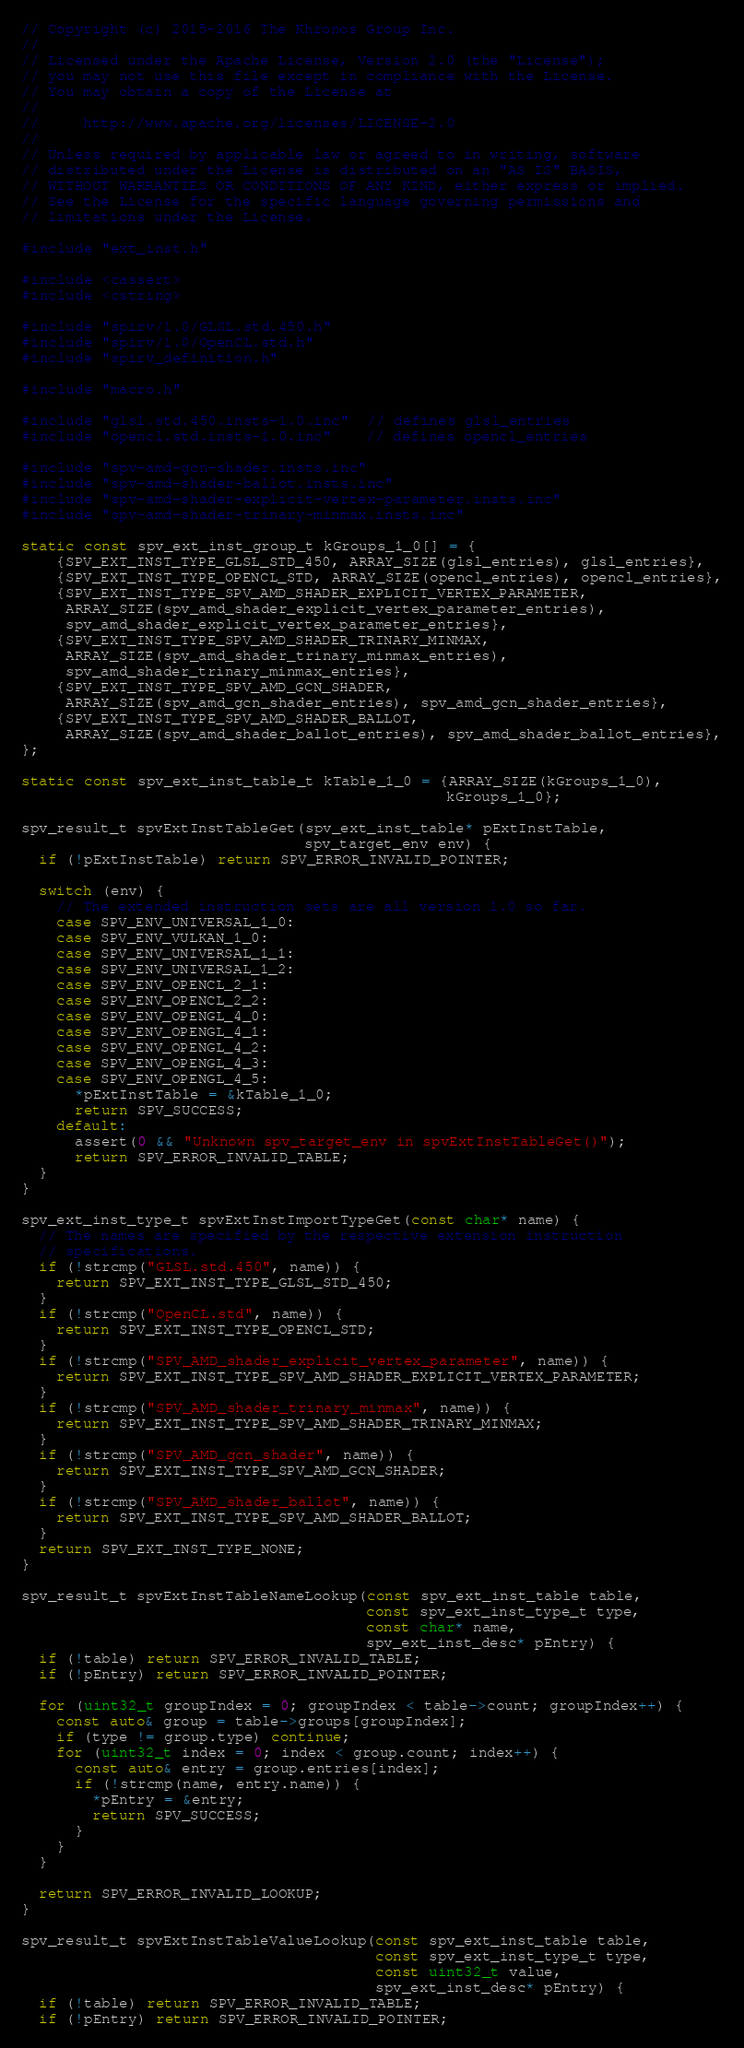Convert code to text. <code><loc_0><loc_0><loc_500><loc_500><_C++_>// Copyright (c) 2015-2016 The Khronos Group Inc.
//
// Licensed under the Apache License, Version 2.0 (the "License");
// you may not use this file except in compliance with the License.
// You may obtain a copy of the License at
//
//     http://www.apache.org/licenses/LICENSE-2.0
//
// Unless required by applicable law or agreed to in writing, software
// distributed under the License is distributed on an "AS IS" BASIS,
// WITHOUT WARRANTIES OR CONDITIONS OF ANY KIND, either express or implied.
// See the License for the specific language governing permissions and
// limitations under the License.

#include "ext_inst.h"

#include <cassert>
#include <cstring>

#include "spirv/1.0/GLSL.std.450.h"
#include "spirv/1.0/OpenCL.std.h"
#include "spirv_definition.h"

#include "macro.h"

#include "glsl.std.450.insts-1.0.inc"  // defines glsl_entries
#include "opencl.std.insts-1.0.inc"    // defines opencl_entries

#include "spv-amd-gcn-shader.insts.inc"
#include "spv-amd-shader-ballot.insts.inc"
#include "spv-amd-shader-explicit-vertex-parameter.insts.inc"
#include "spv-amd-shader-trinary-minmax.insts.inc"

static const spv_ext_inst_group_t kGroups_1_0[] = {
    {SPV_EXT_INST_TYPE_GLSL_STD_450, ARRAY_SIZE(glsl_entries), glsl_entries},
    {SPV_EXT_INST_TYPE_OPENCL_STD, ARRAY_SIZE(opencl_entries), opencl_entries},
    {SPV_EXT_INST_TYPE_SPV_AMD_SHADER_EXPLICIT_VERTEX_PARAMETER,
     ARRAY_SIZE(spv_amd_shader_explicit_vertex_parameter_entries),
     spv_amd_shader_explicit_vertex_parameter_entries},
    {SPV_EXT_INST_TYPE_SPV_AMD_SHADER_TRINARY_MINMAX,
     ARRAY_SIZE(spv_amd_shader_trinary_minmax_entries),
     spv_amd_shader_trinary_minmax_entries},
    {SPV_EXT_INST_TYPE_SPV_AMD_GCN_SHADER,
     ARRAY_SIZE(spv_amd_gcn_shader_entries), spv_amd_gcn_shader_entries},
    {SPV_EXT_INST_TYPE_SPV_AMD_SHADER_BALLOT,
     ARRAY_SIZE(spv_amd_shader_ballot_entries), spv_amd_shader_ballot_entries},
};

static const spv_ext_inst_table_t kTable_1_0 = {ARRAY_SIZE(kGroups_1_0),
                                                kGroups_1_0};

spv_result_t spvExtInstTableGet(spv_ext_inst_table* pExtInstTable,
                                spv_target_env env) {
  if (!pExtInstTable) return SPV_ERROR_INVALID_POINTER;

  switch (env) {
    // The extended instruction sets are all version 1.0 so far.
    case SPV_ENV_UNIVERSAL_1_0:
    case SPV_ENV_VULKAN_1_0:
    case SPV_ENV_UNIVERSAL_1_1:
    case SPV_ENV_UNIVERSAL_1_2:
    case SPV_ENV_OPENCL_2_1:
    case SPV_ENV_OPENCL_2_2:
    case SPV_ENV_OPENGL_4_0:
    case SPV_ENV_OPENGL_4_1:
    case SPV_ENV_OPENGL_4_2:
    case SPV_ENV_OPENGL_4_3:
    case SPV_ENV_OPENGL_4_5:
      *pExtInstTable = &kTable_1_0;
      return SPV_SUCCESS;
    default:
      assert(0 && "Unknown spv_target_env in spvExtInstTableGet()");
      return SPV_ERROR_INVALID_TABLE;
  }
}

spv_ext_inst_type_t spvExtInstImportTypeGet(const char* name) {
  // The names are specified by the respective extension instruction
  // specifications.
  if (!strcmp("GLSL.std.450", name)) {
    return SPV_EXT_INST_TYPE_GLSL_STD_450;
  }
  if (!strcmp("OpenCL.std", name)) {
    return SPV_EXT_INST_TYPE_OPENCL_STD;
  }
  if (!strcmp("SPV_AMD_shader_explicit_vertex_parameter", name)) {
    return SPV_EXT_INST_TYPE_SPV_AMD_SHADER_EXPLICIT_VERTEX_PARAMETER;
  }
  if (!strcmp("SPV_AMD_shader_trinary_minmax", name)) {
    return SPV_EXT_INST_TYPE_SPV_AMD_SHADER_TRINARY_MINMAX;
  }
  if (!strcmp("SPV_AMD_gcn_shader", name)) {
    return SPV_EXT_INST_TYPE_SPV_AMD_GCN_SHADER;
  }
  if (!strcmp("SPV_AMD_shader_ballot", name)) {
    return SPV_EXT_INST_TYPE_SPV_AMD_SHADER_BALLOT;
  }
  return SPV_EXT_INST_TYPE_NONE;
}

spv_result_t spvExtInstTableNameLookup(const spv_ext_inst_table table,
                                       const spv_ext_inst_type_t type,
                                       const char* name,
                                       spv_ext_inst_desc* pEntry) {
  if (!table) return SPV_ERROR_INVALID_TABLE;
  if (!pEntry) return SPV_ERROR_INVALID_POINTER;

  for (uint32_t groupIndex = 0; groupIndex < table->count; groupIndex++) {
    const auto& group = table->groups[groupIndex];
    if (type != group.type) continue;
    for (uint32_t index = 0; index < group.count; index++) {
      const auto& entry = group.entries[index];
      if (!strcmp(name, entry.name)) {
        *pEntry = &entry;
        return SPV_SUCCESS;
      }
    }
  }

  return SPV_ERROR_INVALID_LOOKUP;
}

spv_result_t spvExtInstTableValueLookup(const spv_ext_inst_table table,
                                        const spv_ext_inst_type_t type,
                                        const uint32_t value,
                                        spv_ext_inst_desc* pEntry) {
  if (!table) return SPV_ERROR_INVALID_TABLE;
  if (!pEntry) return SPV_ERROR_INVALID_POINTER;
</code> 